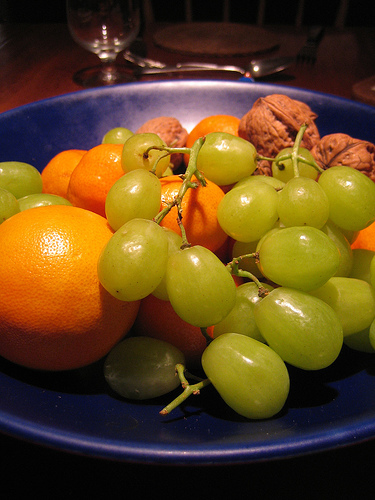<image>
Can you confirm if the grapes is on the orange? Yes. Looking at the image, I can see the grapes is positioned on top of the orange, with the orange providing support. Is the green grape under the orange? Yes. The green grape is positioned underneath the orange, with the orange above it in the vertical space. Is the grapes behind the oranges? No. The grapes is not behind the oranges. From this viewpoint, the grapes appears to be positioned elsewhere in the scene. 